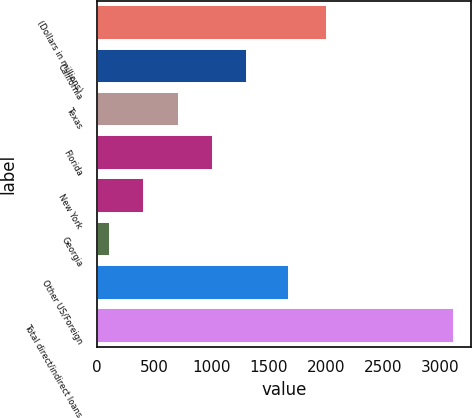Convert chart. <chart><loc_0><loc_0><loc_500><loc_500><bar_chart><fcel>(Dollars in millions)<fcel>California<fcel>Texas<fcel>Florida<fcel>New York<fcel>Georgia<fcel>Other US/Foreign<fcel>Total direct/indirect loans<nl><fcel>2008<fcel>1314.6<fcel>714.8<fcel>1014.7<fcel>414.9<fcel>115<fcel>1680<fcel>3114<nl></chart> 